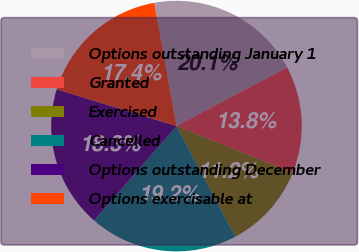Convert chart to OTSL. <chart><loc_0><loc_0><loc_500><loc_500><pie_chart><fcel>Options outstanding January 1<fcel>Granted<fcel>Exercised<fcel>Cancelled<fcel>Options outstanding December<fcel>Options exercisable at<nl><fcel>20.07%<fcel>13.84%<fcel>11.15%<fcel>19.19%<fcel>18.31%<fcel>17.43%<nl></chart> 